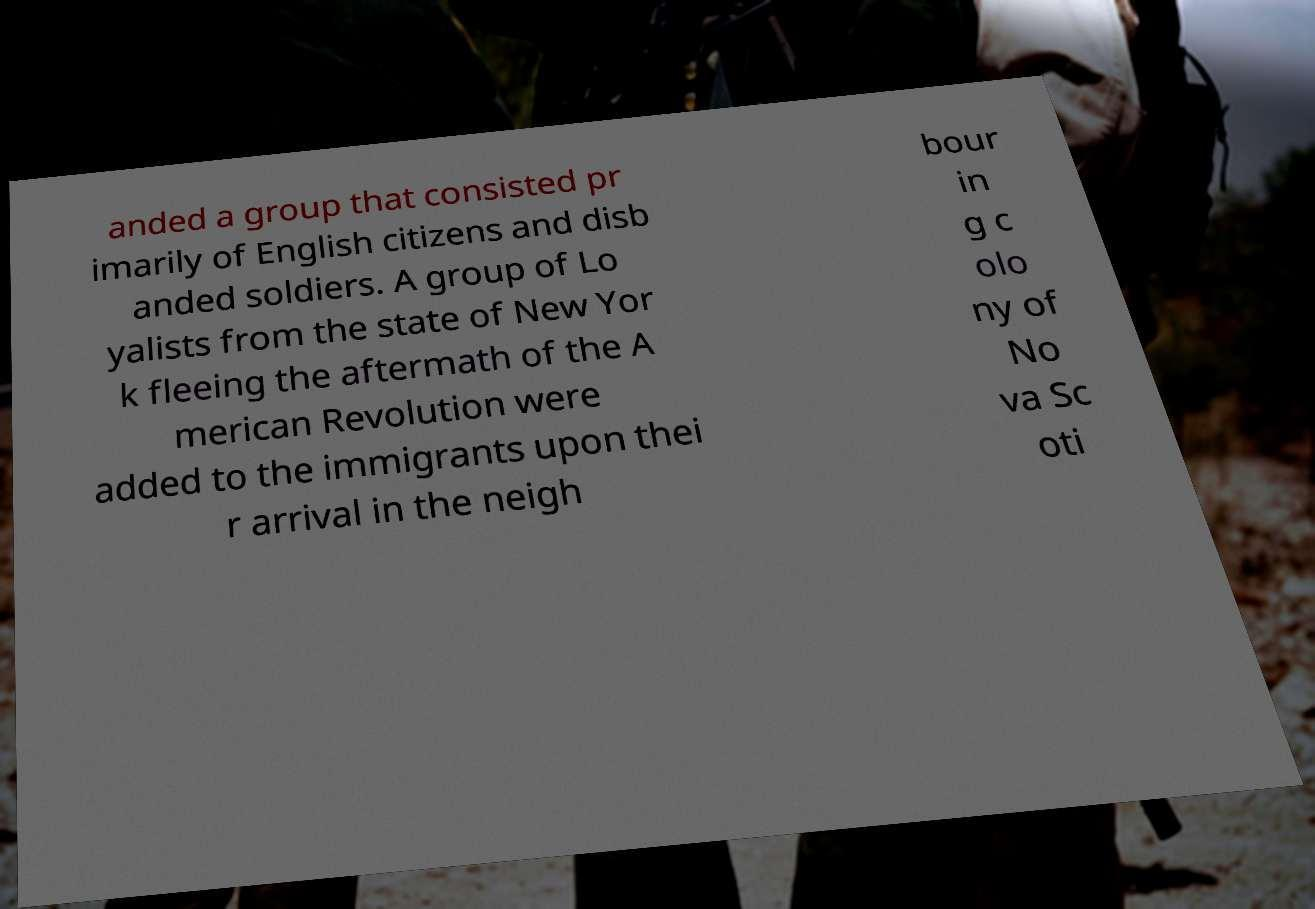Please identify and transcribe the text found in this image. anded a group that consisted pr imarily of English citizens and disb anded soldiers. A group of Lo yalists from the state of New Yor k fleeing the aftermath of the A merican Revolution were added to the immigrants upon thei r arrival in the neigh bour in g c olo ny of No va Sc oti 